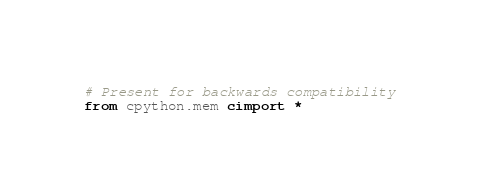<code> <loc_0><loc_0><loc_500><loc_500><_Cython_># Present for backwards compatibility
from cpython.mem cimport *
</code> 